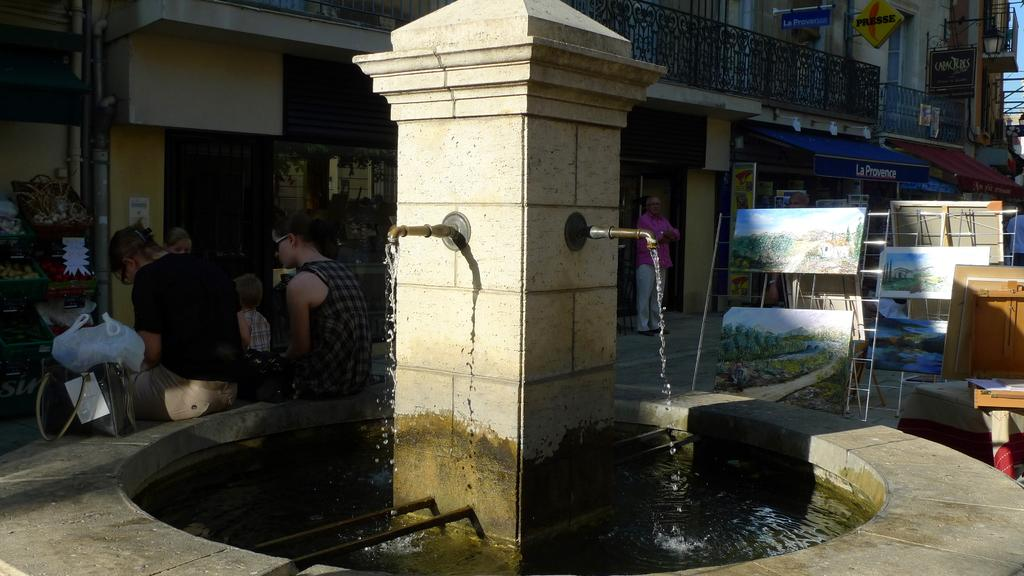What type of structures can be seen in the image? There are buildings in the image. What is the purpose of the fence in the image? The purpose of the fence in the image is not clear, but it could be for enclosing an area or providing a barrier. What is the pipe in the image used for? The purpose of the pipe in the image is not clear, but it could be for carrying water, gas, or other substances. What is the liquid visible in the image? There is water visible in the image. Who are the individuals in the image? There is a group of people in the image. What is the ladder used for in the image? The ladder in the image could be used for reaching higher areas or as a support for climbing. How would you describe the lighting in the image? The image is a little dark. How many eggs are being held by the sisters in the image? There are no sisters or eggs present in the image. What type of harbor can be seen in the image? There is no harbor present in the image. 